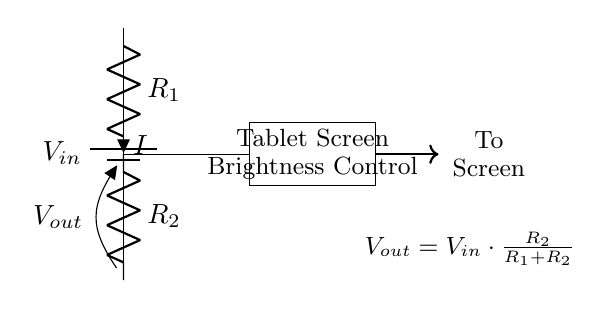What is the purpose of the resistors in this circuit? The resistors R1 and R2 form a voltage divider to adjust the output voltage; R1 limits current while R2 determines the ratio of output voltage to input voltage.
Answer: Adjusting output voltage What does Vout represent? Vout is the output voltage from the voltage divider circuit that will control the brightness of the tablet screen, as indicated in the circuit diagram.
Answer: Output voltage What happens if R1 is increased? Increasing R1 will result in a lower Vout because it increases the resistance for the current, which reduces the proportion of Vout based on the voltage divider formula Vout = Vin * R2 / (R1 + R2).
Answer: Vout decreases What is the current flowing through R1 and R2? The current I flowing through both resistors is the same in a series circuit and can be calculated depending on input voltage and the total resistance (R1 + R2).
Answer: I What is the formula for calculating Vout? Vout is calculated using the voltage divider formula provided in the diagram, which states that Vout is equal to Vin multiplied by the ratio of R2 over the total resistance (R1 + R2).
Answer: Vout = Vin * R2 / (R1 + R2) What would happen if R2 is much smaller than R1? If R2 is much smaller than R1, then the output voltage Vout will be very low; essentially, the circuit will provide less brightness to the tablet screen due to the high resistance of R1 compared to R2.
Answer: Vout will be low 